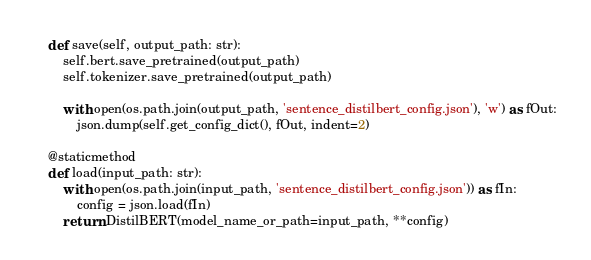Convert code to text. <code><loc_0><loc_0><loc_500><loc_500><_Python_>    def save(self, output_path: str):
        self.bert.save_pretrained(output_path)
        self.tokenizer.save_pretrained(output_path)

        with open(os.path.join(output_path, 'sentence_distilbert_config.json'), 'w') as fOut:
            json.dump(self.get_config_dict(), fOut, indent=2)

    @staticmethod
    def load(input_path: str):
        with open(os.path.join(input_path, 'sentence_distilbert_config.json')) as fIn:
            config = json.load(fIn)
        return DistilBERT(model_name_or_path=input_path, **config)






</code> 